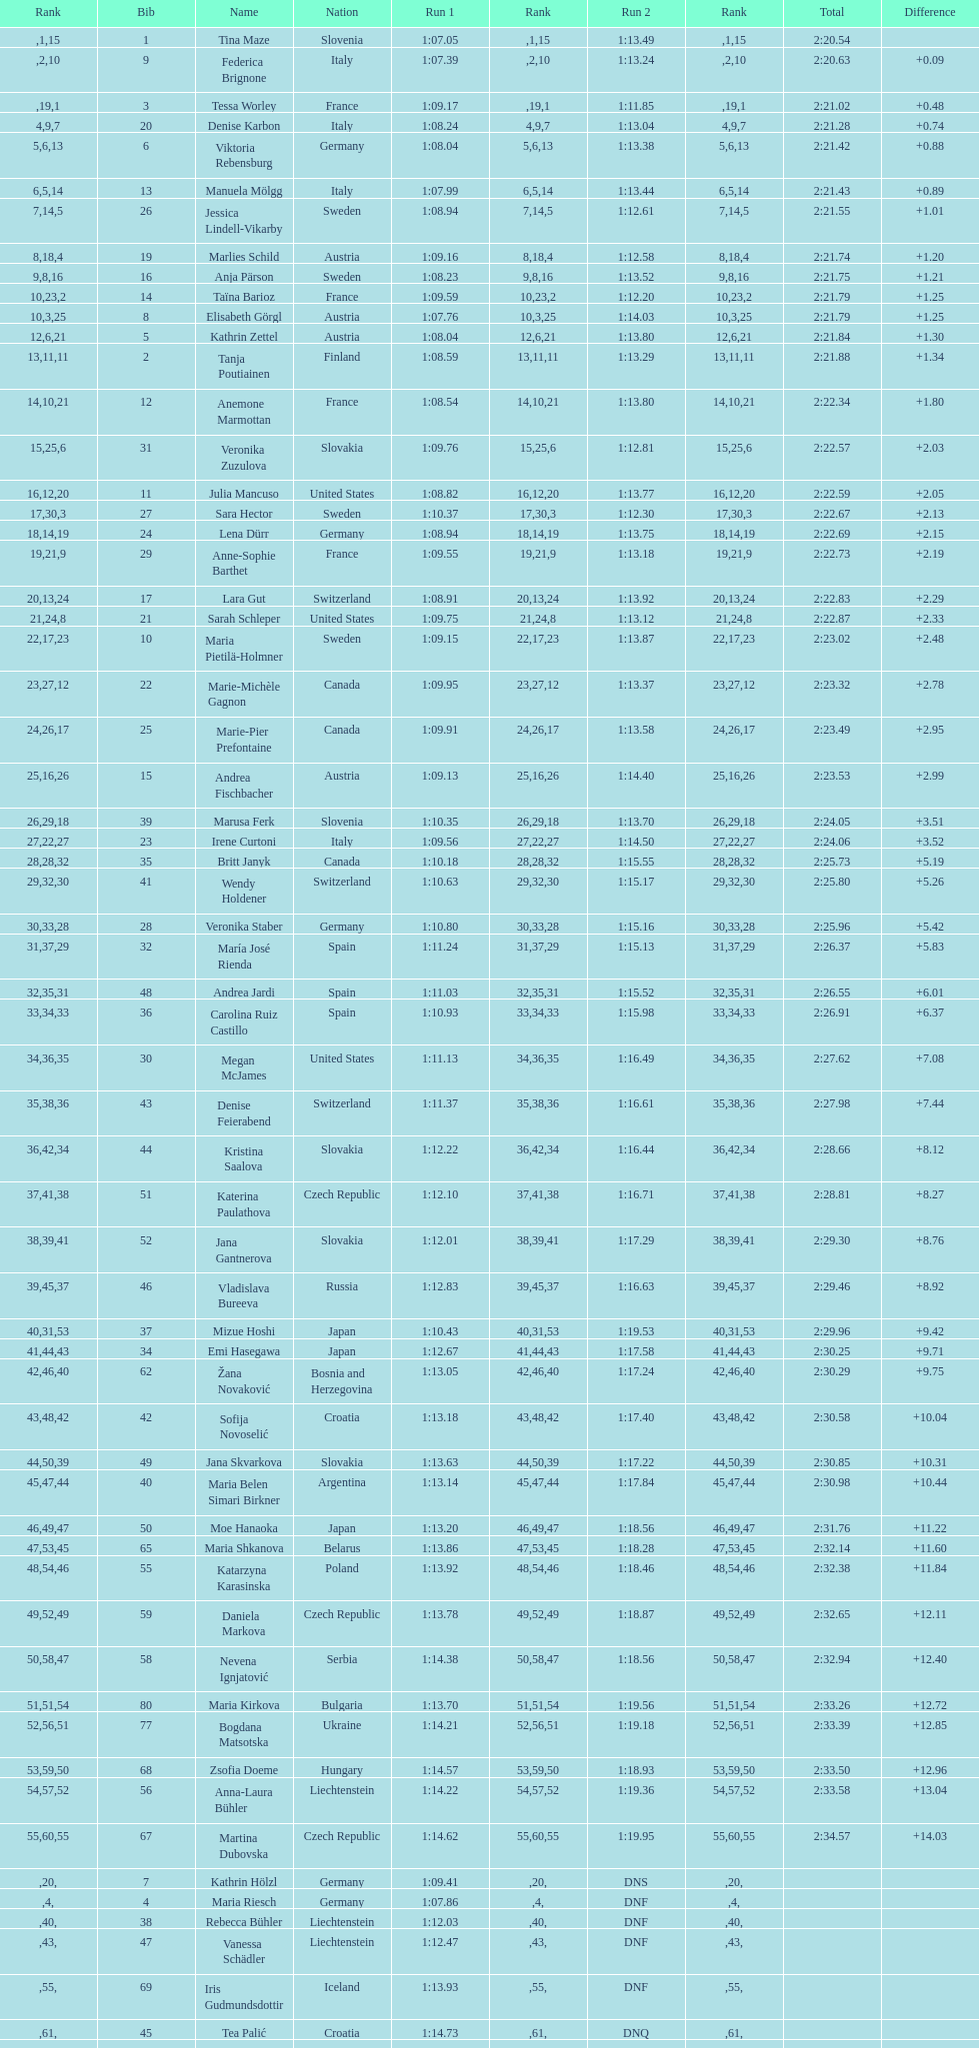How many athletes had the same position for both run 1 and run 2? 1. 